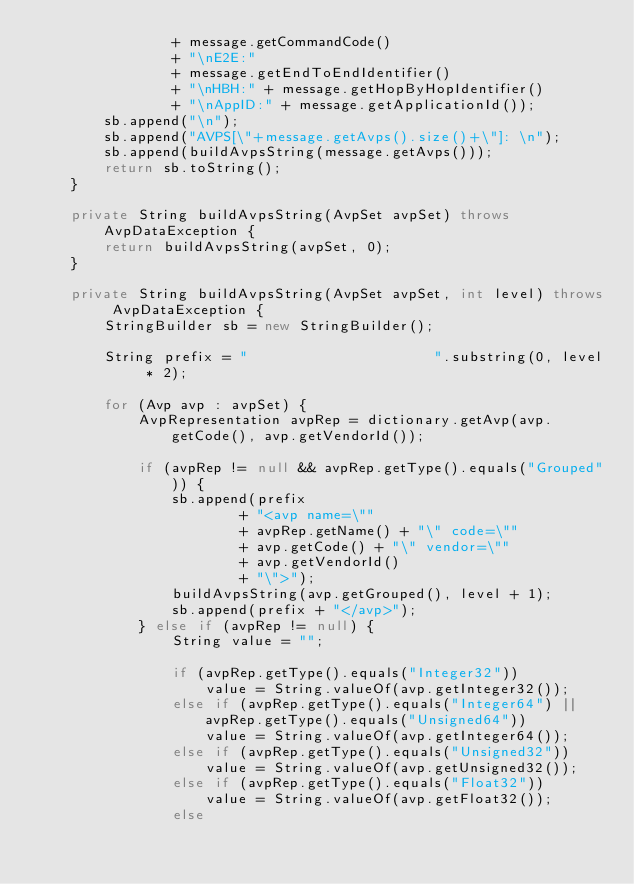Convert code to text. <code><loc_0><loc_0><loc_500><loc_500><_Java_>                + message.getCommandCode()
                + "\nE2E:"
                + message.getEndToEndIdentifier()
                + "\nHBH:" + message.getHopByHopIdentifier()
                + "\nAppID:" + message.getApplicationId());
        sb.append("\n");
        sb.append("AVPS[\"+message.getAvps().size()+\"]: \n");
        sb.append(buildAvpsString(message.getAvps()));
        return sb.toString();
    }

    private String buildAvpsString(AvpSet avpSet) throws AvpDataException {
        return buildAvpsString(avpSet, 0);
    }

    private String buildAvpsString(AvpSet avpSet, int level) throws AvpDataException {
        StringBuilder sb = new StringBuilder();

        String prefix = "                      ".substring(0, level * 2);

        for (Avp avp : avpSet) {
            AvpRepresentation avpRep = dictionary.getAvp(avp.getCode(), avp.getVendorId());

            if (avpRep != null && avpRep.getType().equals("Grouped")) {
                sb.append(prefix
                        + "<avp name=\""
                        + avpRep.getName() + "\" code=\""
                        + avp.getCode() + "\" vendor=\""
                        + avp.getVendorId()
                        + "\">");
                buildAvpsString(avp.getGrouped(), level + 1);
                sb.append(prefix + "</avp>");
            } else if (avpRep != null) {
                String value = "";

                if (avpRep.getType().equals("Integer32"))
                    value = String.valueOf(avp.getInteger32());
                else if (avpRep.getType().equals("Integer64") || avpRep.getType().equals("Unsigned64"))
                    value = String.valueOf(avp.getInteger64());
                else if (avpRep.getType().equals("Unsigned32"))
                    value = String.valueOf(avp.getUnsigned32());
                else if (avpRep.getType().equals("Float32"))
                    value = String.valueOf(avp.getFloat32());
                else</code> 